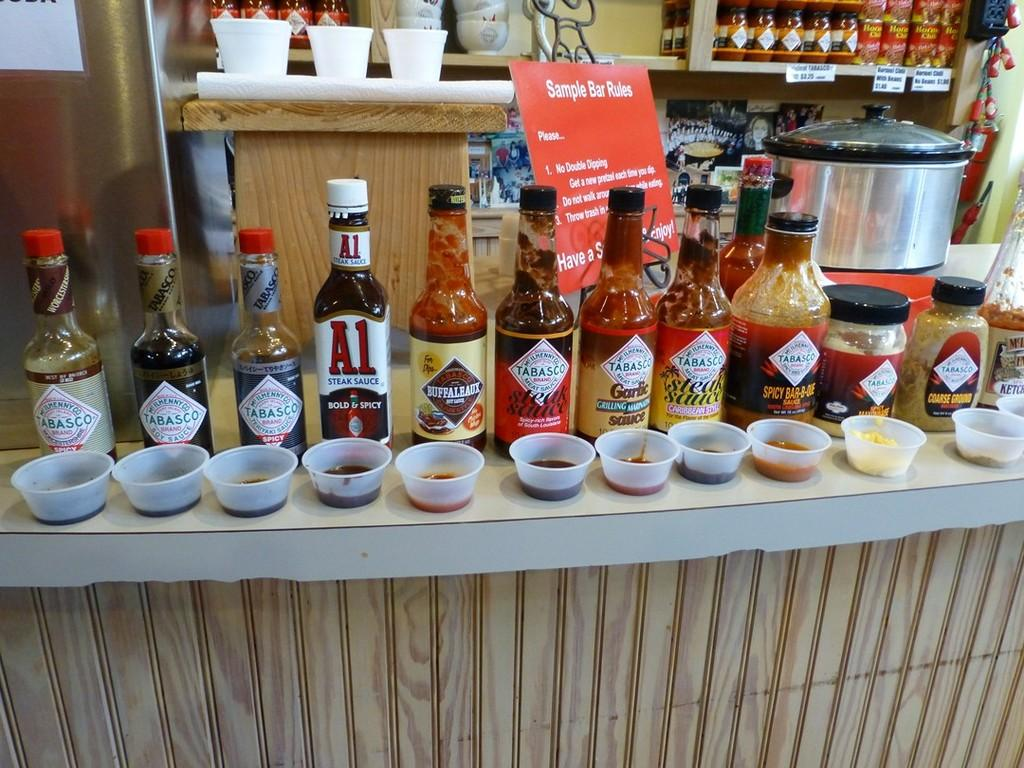Provide a one-sentence caption for the provided image. A few bottles of sauces next to each other including tobasco. 